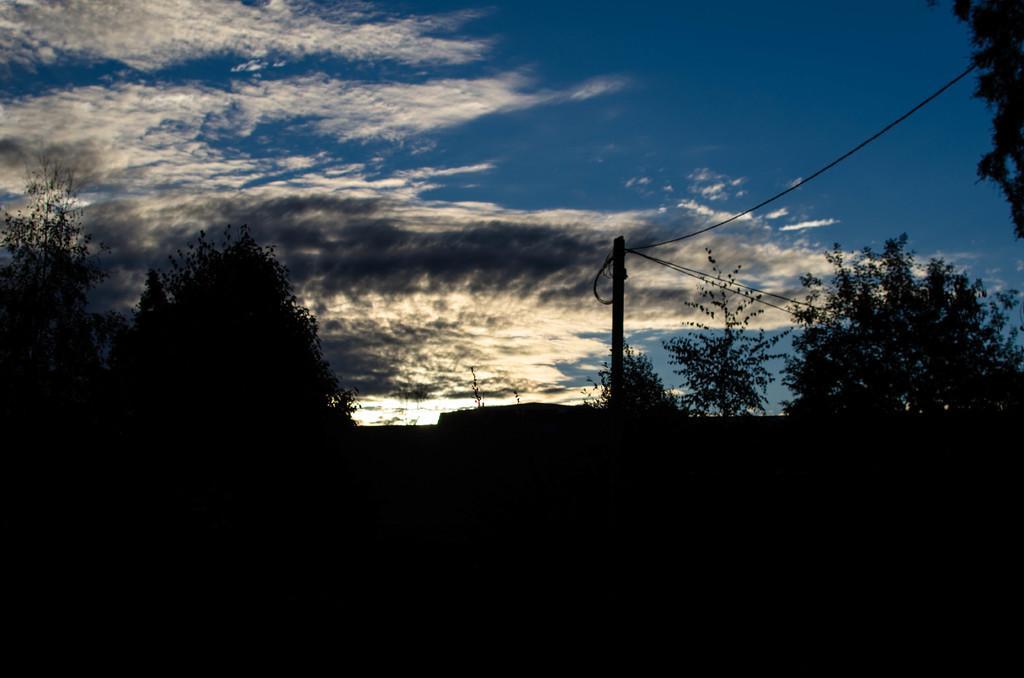Can you describe this image briefly? In this picture I can observe some trees. There is a pole on the right side of the picture. In the background I can observe some clouds in the sky. 